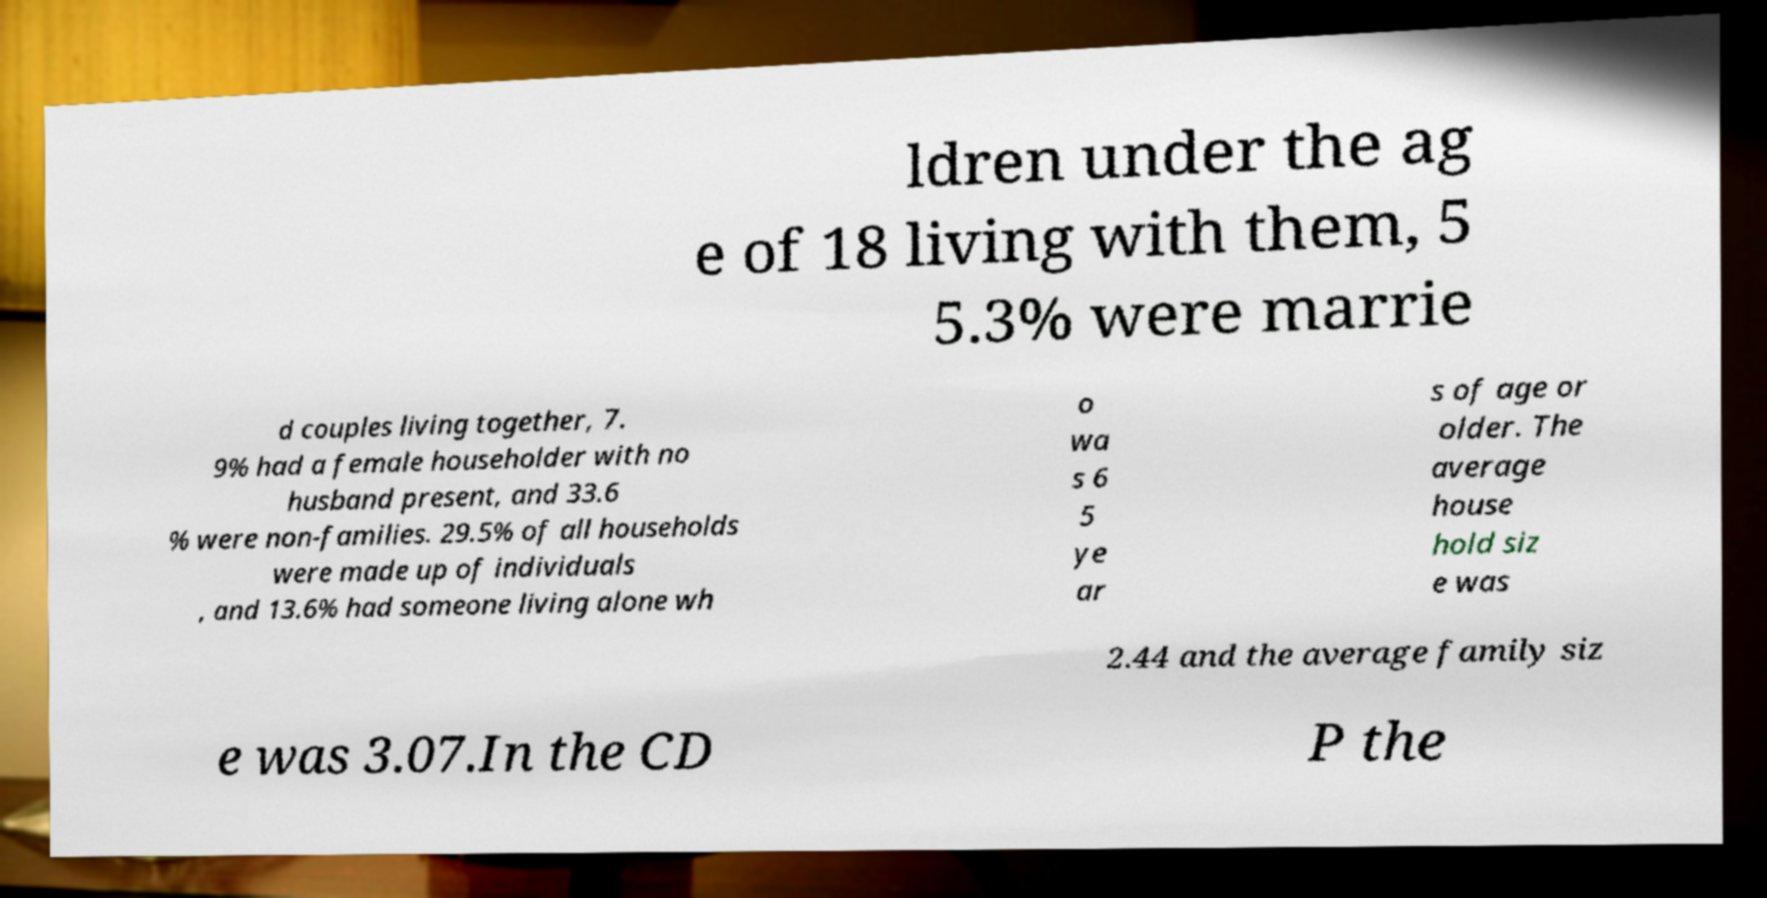Could you extract and type out the text from this image? ldren under the ag e of 18 living with them, 5 5.3% were marrie d couples living together, 7. 9% had a female householder with no husband present, and 33.6 % were non-families. 29.5% of all households were made up of individuals , and 13.6% had someone living alone wh o wa s 6 5 ye ar s of age or older. The average house hold siz e was 2.44 and the average family siz e was 3.07.In the CD P the 